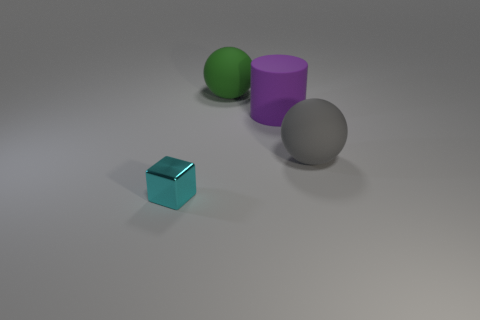Are there any other things that are the same shape as the cyan object?
Make the answer very short. No. Are there more balls in front of the rubber cylinder than matte spheres to the right of the big green object?
Your response must be concise. No. There is a matte sphere on the left side of the big rubber ball that is on the right side of the ball that is behind the large purple thing; what is its size?
Your answer should be very brief. Large. Are the big gray ball and the tiny cyan thing in front of the gray object made of the same material?
Provide a succinct answer. No. Is the small cyan object the same shape as the gray thing?
Give a very brief answer. No. How many other objects are the same material as the big green object?
Provide a succinct answer. 2. What number of other things have the same shape as the big green object?
Offer a terse response. 1. What is the color of the object that is both left of the rubber cylinder and behind the large gray sphere?
Your response must be concise. Green. What number of big green things are there?
Provide a succinct answer. 1. Is the size of the purple matte cylinder the same as the cyan object?
Provide a succinct answer. No. 